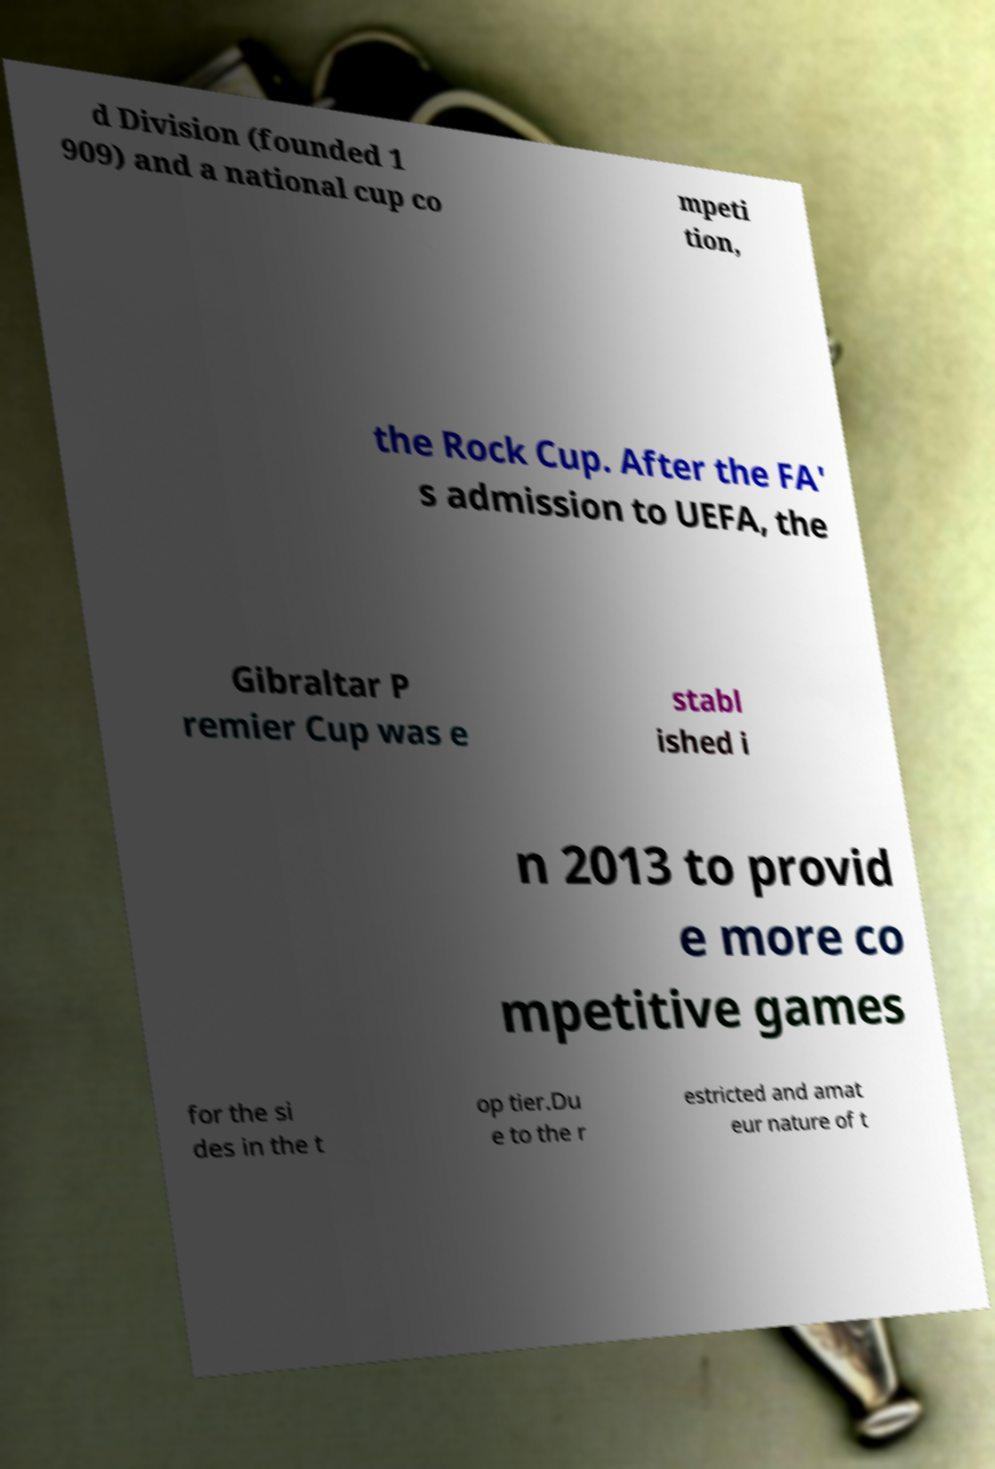There's text embedded in this image that I need extracted. Can you transcribe it verbatim? d Division (founded 1 909) and a national cup co mpeti tion, the Rock Cup. After the FA' s admission to UEFA, the Gibraltar P remier Cup was e stabl ished i n 2013 to provid e more co mpetitive games for the si des in the t op tier.Du e to the r estricted and amat eur nature of t 